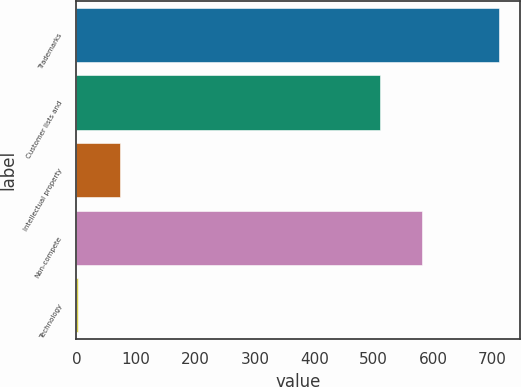<chart> <loc_0><loc_0><loc_500><loc_500><bar_chart><fcel>Trademarks<fcel>Customer lists and<fcel>Intellectual property<fcel>Non-compete<fcel>Technology<nl><fcel>710<fcel>510<fcel>73.7<fcel>580.7<fcel>3<nl></chart> 